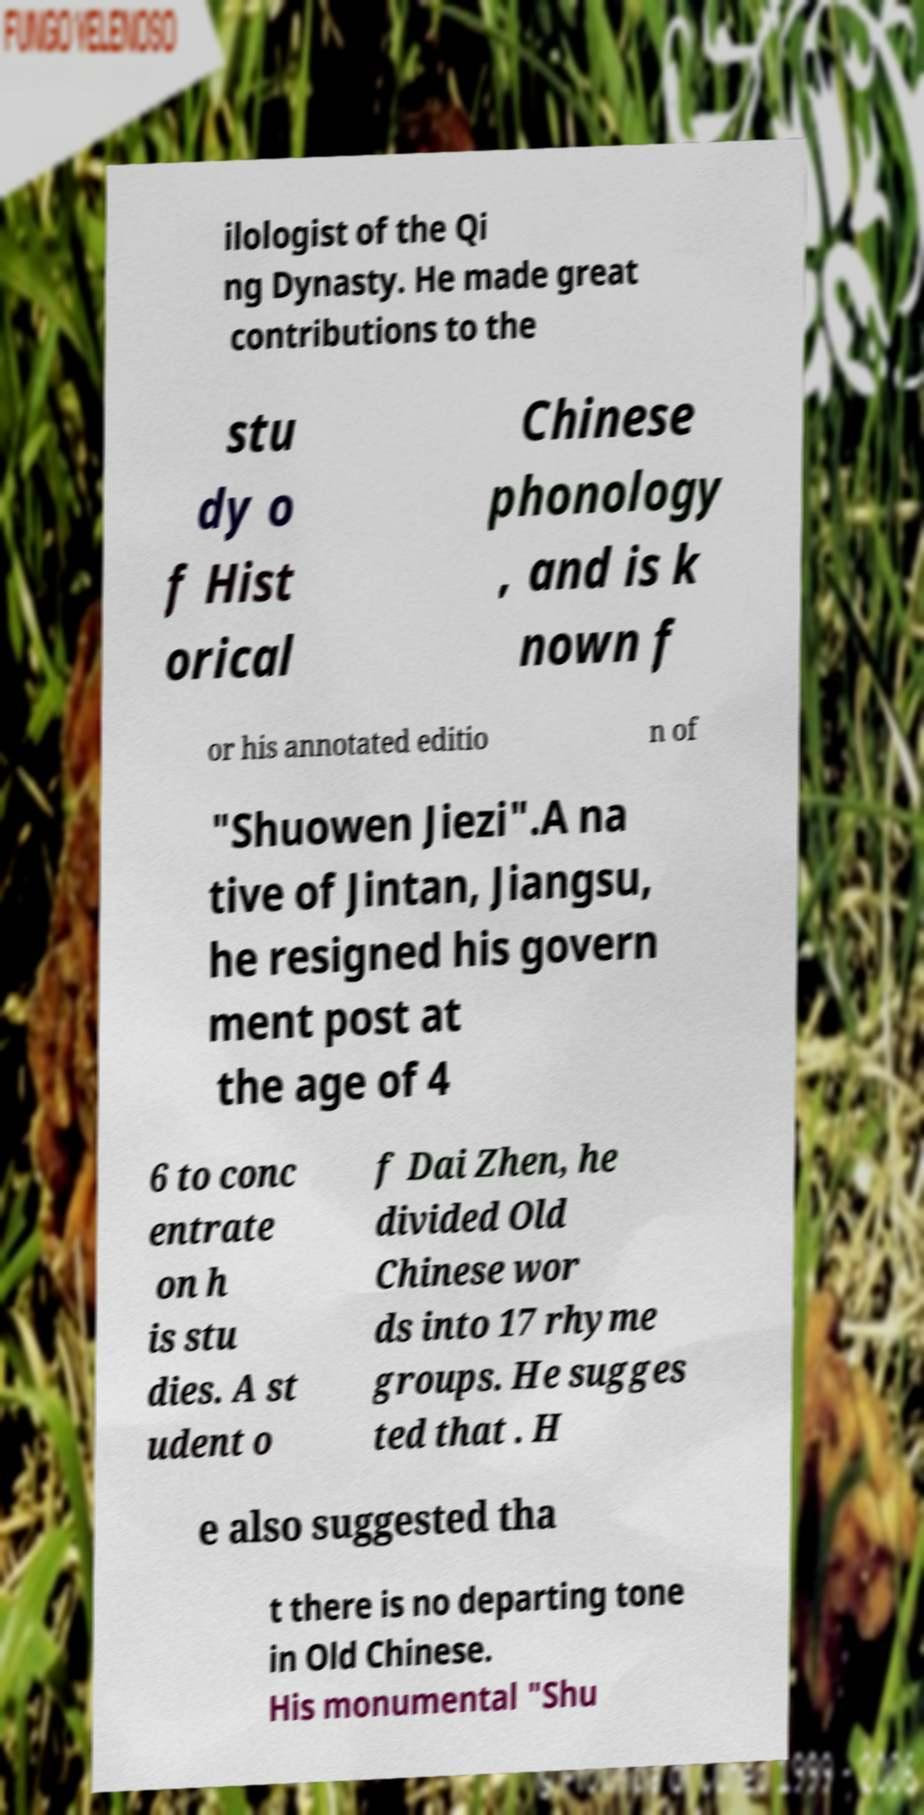I need the written content from this picture converted into text. Can you do that? ilologist of the Qi ng Dynasty. He made great contributions to the stu dy o f Hist orical Chinese phonology , and is k nown f or his annotated editio n of "Shuowen Jiezi".A na tive of Jintan, Jiangsu, he resigned his govern ment post at the age of 4 6 to conc entrate on h is stu dies. A st udent o f Dai Zhen, he divided Old Chinese wor ds into 17 rhyme groups. He sugges ted that . H e also suggested tha t there is no departing tone in Old Chinese. His monumental "Shu 